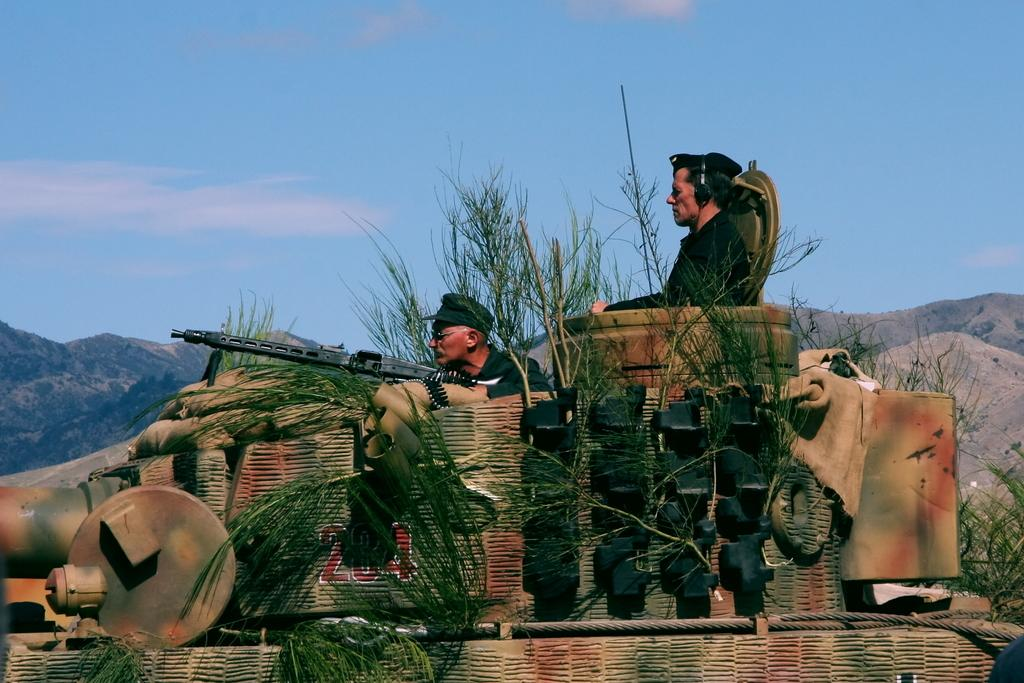What are the people in the image doing? The people in the image are standing in a vehicle. What is the man holding in the image? The man is holding a rifle. What type of natural elements can be seen in the image? There are plants and hills visible in the image. What part of the natural environment is visible in the background? The sky is visible in the background. What type of hammer is being used by the nation in the image? There is no hammer or nation present in the image. How does the coach contribute to the scene in the image? There is no coach present in the image. 